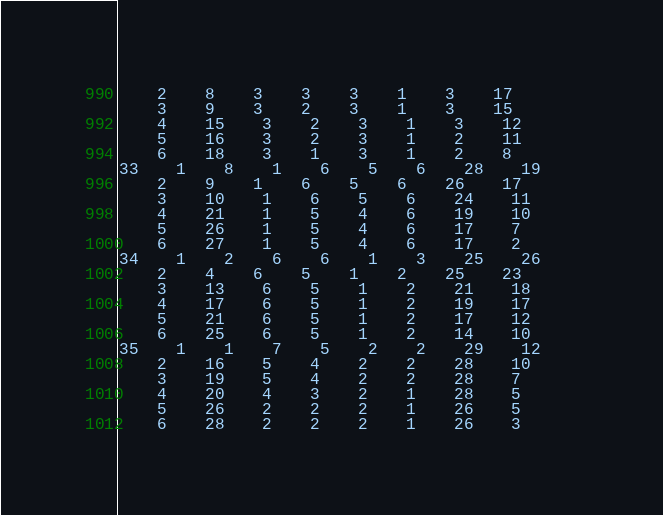Convert code to text. <code><loc_0><loc_0><loc_500><loc_500><_ObjectiveC_>	2	8	3	3	3	1	3	17	
	3	9	3	2	3	1	3	15	
	4	15	3	2	3	1	3	12	
	5	16	3	2	3	1	2	11	
	6	18	3	1	3	1	2	8	
33	1	8	1	6	5	6	28	19	
	2	9	1	6	5	6	26	17	
	3	10	1	6	5	6	24	11	
	4	21	1	5	4	6	19	10	
	5	26	1	5	4	6	17	7	
	6	27	1	5	4	6	17	2	
34	1	2	6	6	1	3	25	26	
	2	4	6	5	1	2	25	23	
	3	13	6	5	1	2	21	18	
	4	17	6	5	1	2	19	17	
	5	21	6	5	1	2	17	12	
	6	25	6	5	1	2	14	10	
35	1	1	7	5	2	2	29	12	
	2	16	5	4	2	2	28	10	
	3	19	5	4	2	2	28	7	
	4	20	4	3	2	1	28	5	
	5	26	2	2	2	1	26	5	
	6	28	2	2	2	1	26	3	</code> 